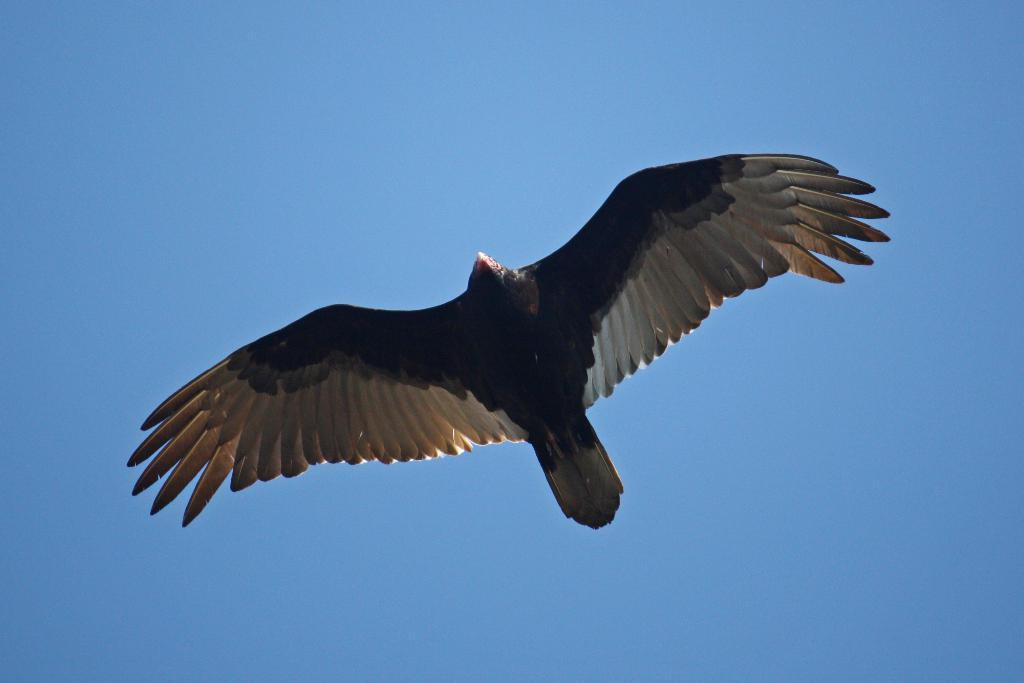What is the main subject of the picture? The main subject of the picture is a big eagle. Can you describe the appearance of the eagle? The eagle has brown and white coloring. What is the eagle doing in the picture? The eagle is flying in the sky, so it is flying. What type of van can be seen in the background of the image? There is no van present in the image; it only features a big eagle flying in the sky. 